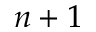Convert formula to latex. <formula><loc_0><loc_0><loc_500><loc_500>n + 1</formula> 